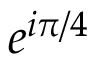Convert formula to latex. <formula><loc_0><loc_0><loc_500><loc_500>e ^ { i \pi / 4 }</formula> 